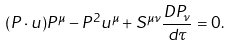Convert formula to latex. <formula><loc_0><loc_0><loc_500><loc_500>( P \cdot u ) P ^ { \mu } - P ^ { 2 } u ^ { \mu } + S ^ { \mu \nu } \frac { D P _ { \nu } } { d \tau } = 0 .</formula> 